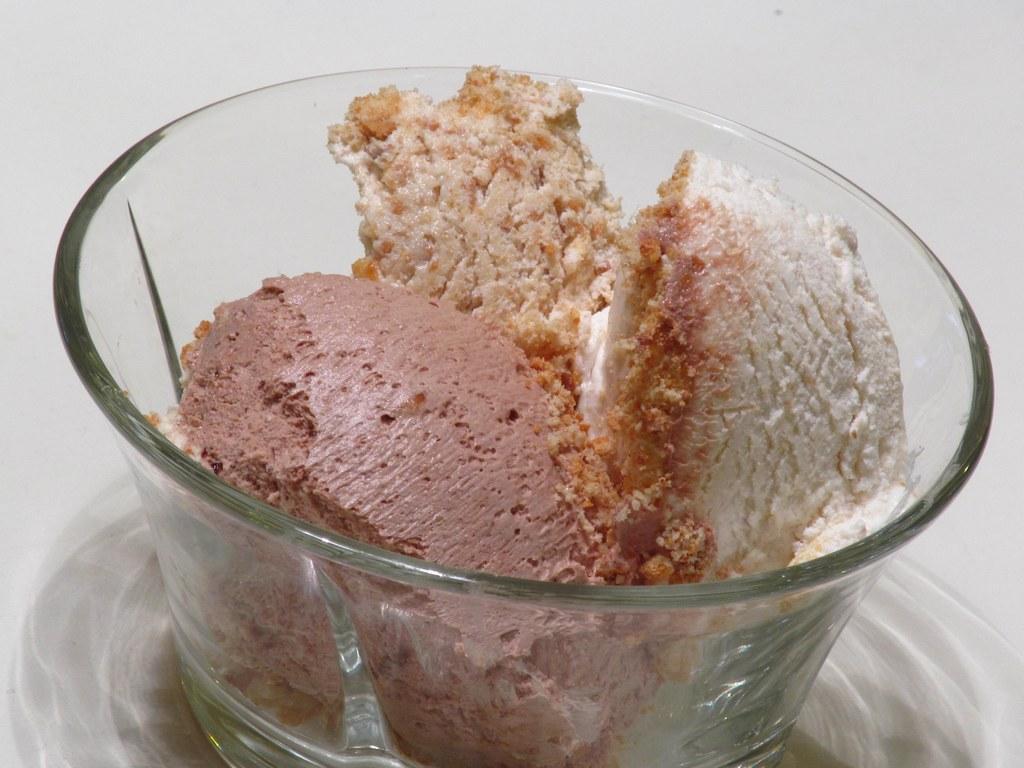In one or two sentences, can you explain what this image depicts? In this picture we can see a glass bowl in the front, there is some food in the bowl, we can see a plane background. 